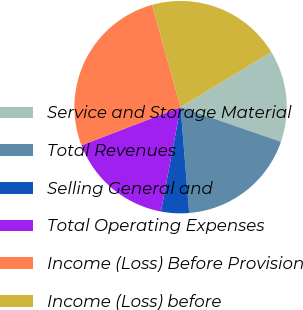<chart> <loc_0><loc_0><loc_500><loc_500><pie_chart><fcel>Service and Storage Material<fcel>Total Revenues<fcel>Selling General and<fcel>Total Operating Expenses<fcel>Income (Loss) Before Provision<fcel>Income (Loss) before<nl><fcel>13.96%<fcel>18.42%<fcel>4.25%<fcel>16.19%<fcel>26.53%<fcel>20.65%<nl></chart> 